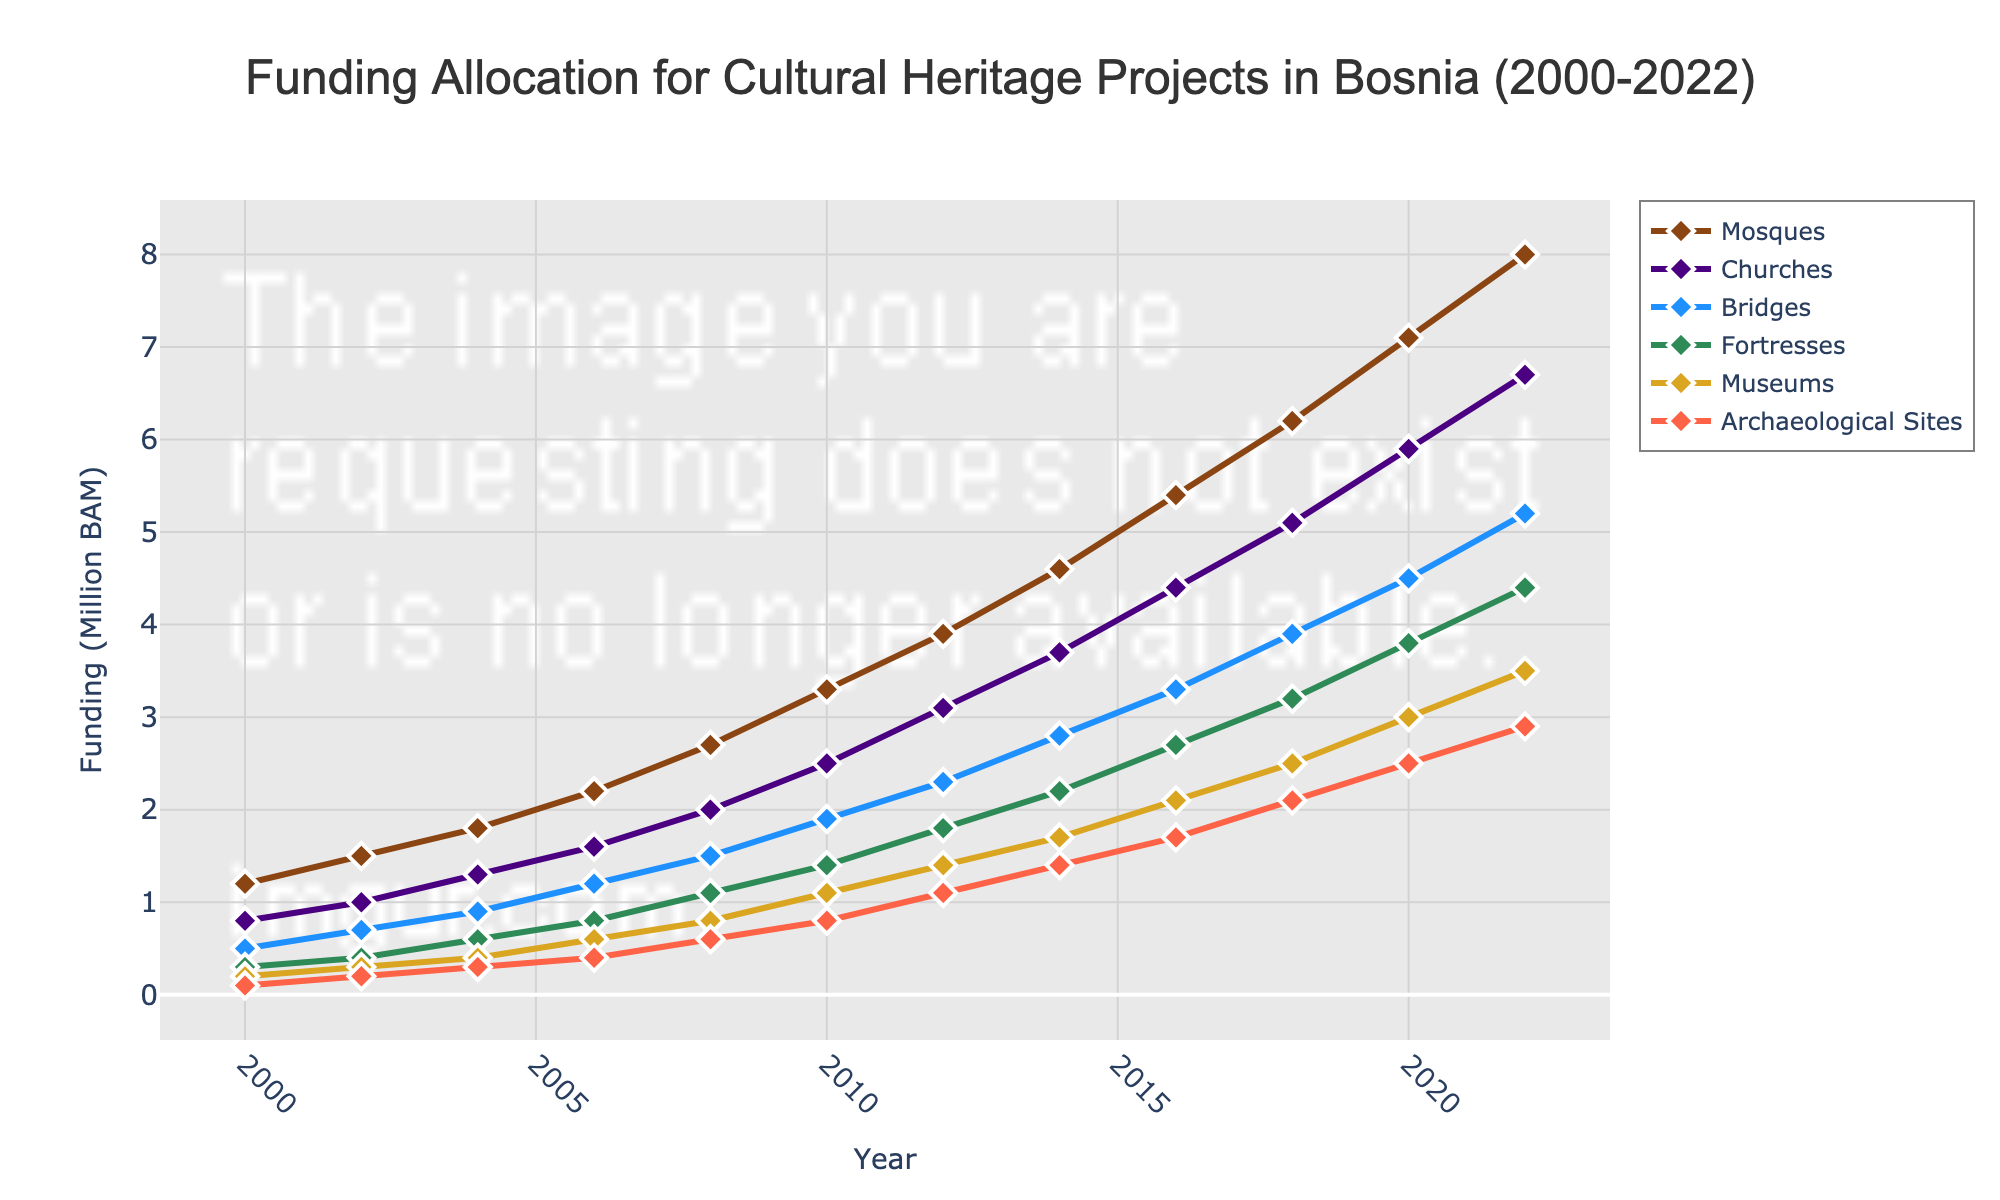What's the trend in funding for mosques from 2000 to 2022? The line representing mosques in the figure consistently rises from 1.2 million BAM in 2000 to 8.0 million BAM in 2022, indicating a steady increase in funding over the years.
Answer: Steadily increasing Which type of site received the highest funding in 2022? In the 2022 section of the figure, the line for mosques is at the highest point compared to other types of sites, indicating that mosques received the highest funding in that year.
Answer: Mosques How does the funding for churches compare to bridges in 2010? In 2010, the figure shows that churches received 2.5 million BAM while bridges received 1.9 million BAM. Comparing the two, churches received more funding than bridges in 2010.
Answer: Churches received more Which type of site saw the largest increase in funding between 2006 and 2016? From 2006 to 2016, the figure shows the steepest rise in the plot for mosques, from 2.2 million BAM to 5.4 million BAM, indicating the largest increase.
Answer: Mosques What is the difference in funding between archaeological sites and museums in 2014? In 2014, archaeological sites had 1.4 million BAM, while museums had 1.7 million BAM. Subtracting the former from the latter gives a difference of 0.3 million BAM.
Answer: 0.3 million BAM Which category had the highest funding growth rate over the entire period? Observing the figure from 2000 to 2022, the line for mosques has the steepest overall slope, indicating the highest growth rate in funding.
Answer: Mosques What is the funding for fortresses in 2008 and how does it compare to the funding for bridges in the same year? In 2008, the figure shows that fortresses received 1.1 million BAM, while bridges received 1.5 million BAM, meaning bridges received more funding.
Answer: Bridges received more If the trends continue, which type of site is projected to have the highest funding in 2024? Extrapolating the trends shown in the figure, the line for mosques consistently rises steeply and is likely to continue to be the highest if the trend persists.
Answer: Mosques What is the average funding for museums from 2000 to 2022? Adding the funding figures for museums from 2000 (0.2), 2002 (0.3), 2004 (0.4), 2006 (0.6), 2008 (0.8), 2010 (1.1), 2012 (1.4), 2014 (1.7), 2016 (2.1), 2018 (2.5), 2020 (3.0), and 2022 (3.5) and dividing by 12 gives (0.2 + 0.3 + 0.4 + 0.6 + 0.8 + 1.1 + 1.4 + 1.7 + 2.1 + 2.5 + 3.0 + 3.5) / 12 = 17.6 / 12 = approximately 1.47 million BAM.
Answer: Approximately 1.47 million BAM Which two types of sites had the closest funding values in 2004, and what are those values? In 2004, the figure shows that museums had 0.4 million BAM, and archaeological sites had 0.3 million BAM. These values are the closest among the plotted categories for that year.
Answer: Museums: 0.4 million BAM, Archaeological Sites: 0.3 million BAM 